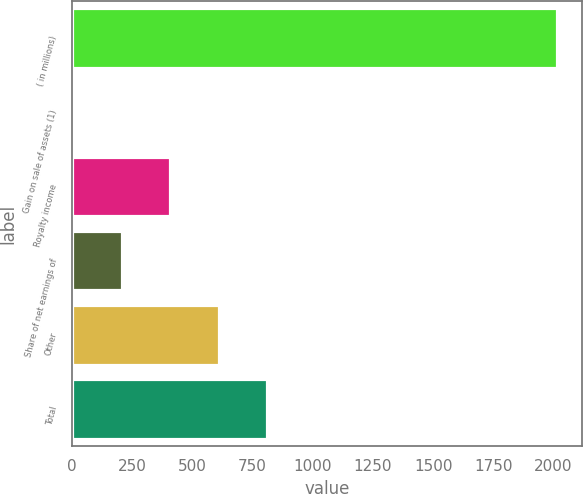Convert chart to OTSL. <chart><loc_0><loc_0><loc_500><loc_500><bar_chart><fcel>( in millions)<fcel>Gain on sale of assets (1)<fcel>Royalty income<fcel>Share of net earnings of<fcel>Other<fcel>Total<nl><fcel>2016<fcel>6<fcel>408<fcel>207<fcel>609<fcel>810<nl></chart> 